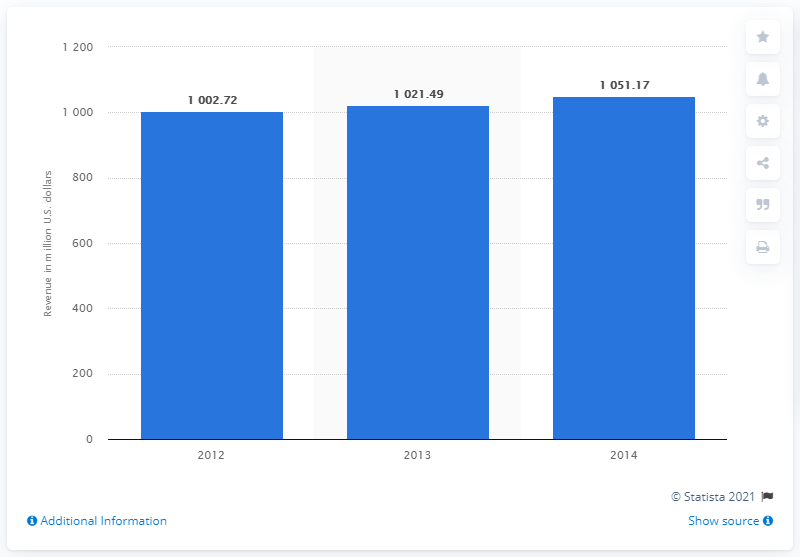Identify some key points in this picture. In 2014, the revenue of the health club chain was 1051.17. 